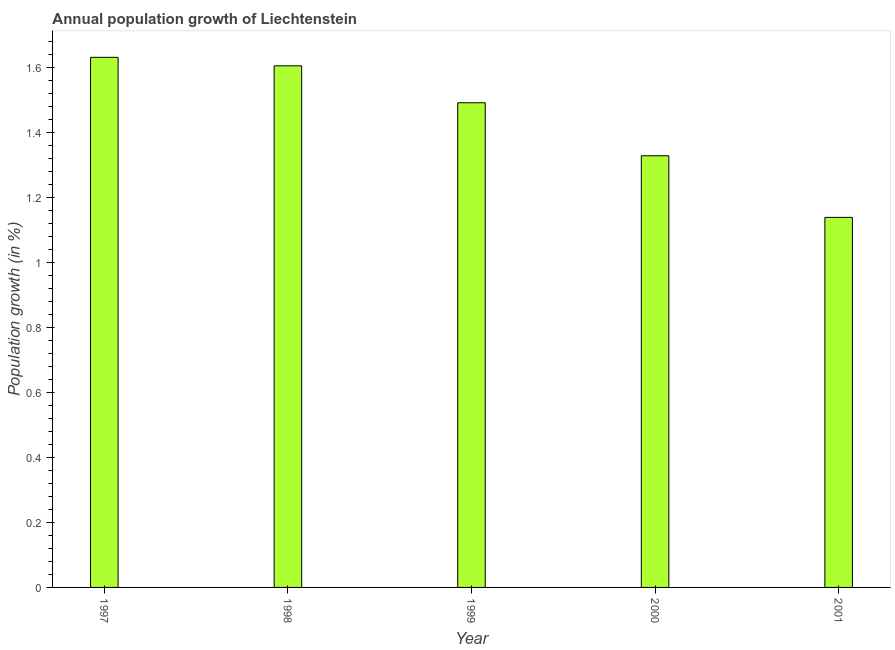Does the graph contain any zero values?
Your answer should be compact. No. Does the graph contain grids?
Keep it short and to the point. No. What is the title of the graph?
Provide a short and direct response. Annual population growth of Liechtenstein. What is the label or title of the Y-axis?
Offer a very short reply. Population growth (in %). What is the population growth in 2001?
Keep it short and to the point. 1.14. Across all years, what is the maximum population growth?
Keep it short and to the point. 1.63. Across all years, what is the minimum population growth?
Your response must be concise. 1.14. What is the sum of the population growth?
Ensure brevity in your answer.  7.19. What is the difference between the population growth in 1998 and 1999?
Provide a short and direct response. 0.11. What is the average population growth per year?
Offer a very short reply. 1.44. What is the median population growth?
Keep it short and to the point. 1.49. What is the ratio of the population growth in 1998 to that in 2000?
Provide a short and direct response. 1.21. What is the difference between the highest and the second highest population growth?
Your answer should be very brief. 0.03. What is the difference between the highest and the lowest population growth?
Your answer should be compact. 0.49. Are all the bars in the graph horizontal?
Provide a short and direct response. No. How many years are there in the graph?
Offer a very short reply. 5. Are the values on the major ticks of Y-axis written in scientific E-notation?
Offer a terse response. No. What is the Population growth (in %) of 1997?
Provide a succinct answer. 1.63. What is the Population growth (in %) of 1998?
Your answer should be compact. 1.6. What is the Population growth (in %) of 1999?
Your response must be concise. 1.49. What is the Population growth (in %) of 2000?
Ensure brevity in your answer.  1.33. What is the Population growth (in %) of 2001?
Offer a very short reply. 1.14. What is the difference between the Population growth (in %) in 1997 and 1998?
Make the answer very short. 0.03. What is the difference between the Population growth (in %) in 1997 and 1999?
Your answer should be compact. 0.14. What is the difference between the Population growth (in %) in 1997 and 2000?
Ensure brevity in your answer.  0.3. What is the difference between the Population growth (in %) in 1997 and 2001?
Keep it short and to the point. 0.49. What is the difference between the Population growth (in %) in 1998 and 1999?
Your answer should be very brief. 0.11. What is the difference between the Population growth (in %) in 1998 and 2000?
Keep it short and to the point. 0.28. What is the difference between the Population growth (in %) in 1998 and 2001?
Offer a terse response. 0.47. What is the difference between the Population growth (in %) in 1999 and 2000?
Provide a succinct answer. 0.16. What is the difference between the Population growth (in %) in 1999 and 2001?
Offer a very short reply. 0.35. What is the difference between the Population growth (in %) in 2000 and 2001?
Provide a short and direct response. 0.19. What is the ratio of the Population growth (in %) in 1997 to that in 1998?
Make the answer very short. 1.02. What is the ratio of the Population growth (in %) in 1997 to that in 1999?
Ensure brevity in your answer.  1.09. What is the ratio of the Population growth (in %) in 1997 to that in 2000?
Offer a very short reply. 1.23. What is the ratio of the Population growth (in %) in 1997 to that in 2001?
Provide a succinct answer. 1.43. What is the ratio of the Population growth (in %) in 1998 to that in 1999?
Your answer should be very brief. 1.08. What is the ratio of the Population growth (in %) in 1998 to that in 2000?
Ensure brevity in your answer.  1.21. What is the ratio of the Population growth (in %) in 1998 to that in 2001?
Give a very brief answer. 1.41. What is the ratio of the Population growth (in %) in 1999 to that in 2000?
Provide a short and direct response. 1.12. What is the ratio of the Population growth (in %) in 1999 to that in 2001?
Provide a succinct answer. 1.31. What is the ratio of the Population growth (in %) in 2000 to that in 2001?
Offer a terse response. 1.17. 